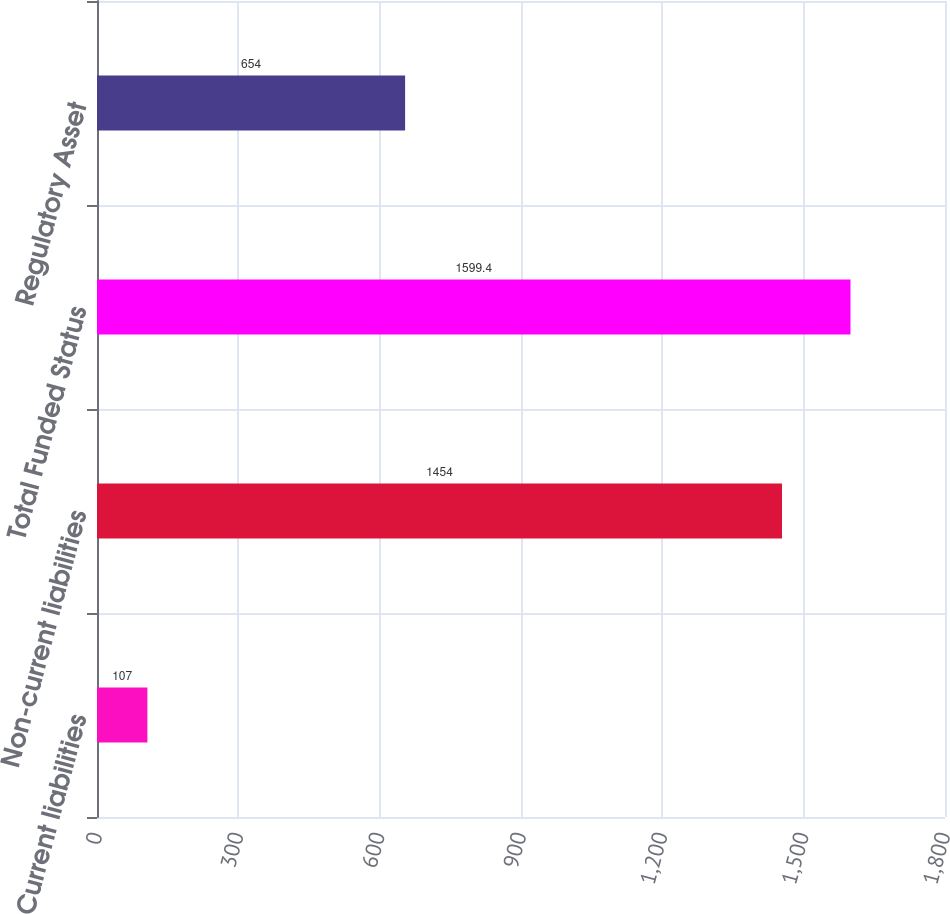Convert chart to OTSL. <chart><loc_0><loc_0><loc_500><loc_500><bar_chart><fcel>Current liabilities<fcel>Non-current liabilities<fcel>Total Funded Status<fcel>Regulatory Asset<nl><fcel>107<fcel>1454<fcel>1599.4<fcel>654<nl></chart> 